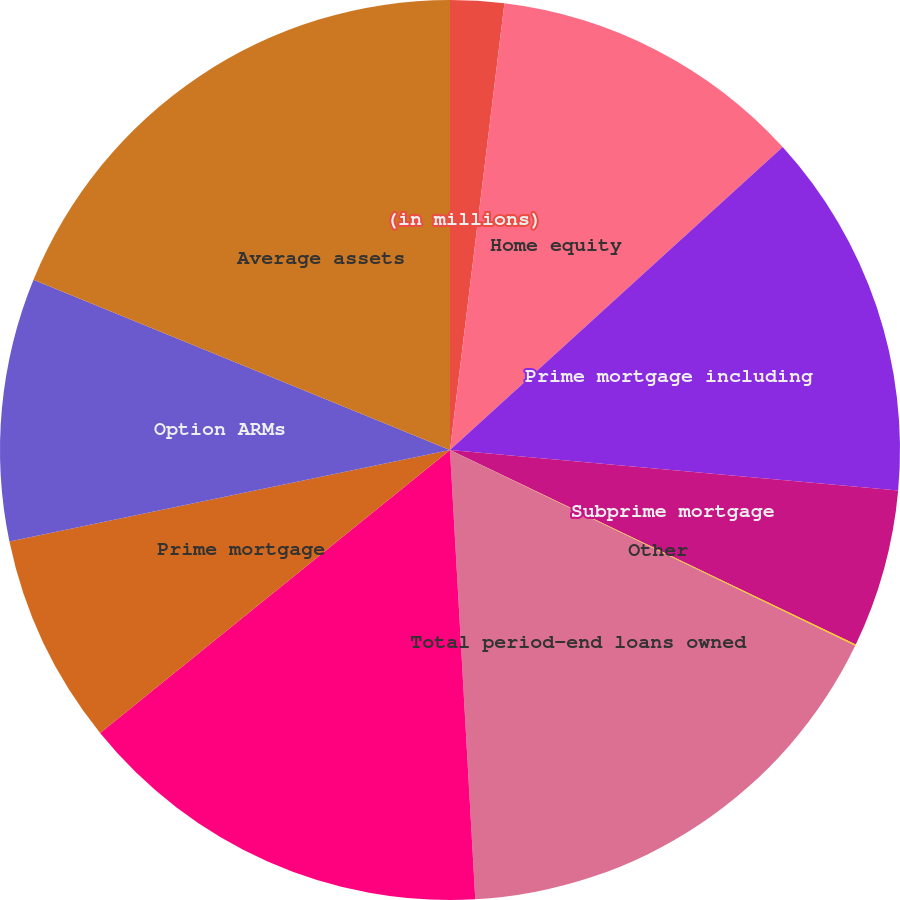Convert chart to OTSL. <chart><loc_0><loc_0><loc_500><loc_500><pie_chart><fcel>(in millions)<fcel>Home equity<fcel>Prime mortgage including<fcel>Subprime mortgage<fcel>Other<fcel>Total period-end loans owned<fcel>Total average loans owned<fcel>Prime mortgage<fcel>Option ARMs<fcel>Average assets<nl><fcel>1.93%<fcel>11.31%<fcel>13.19%<fcel>5.68%<fcel>0.05%<fcel>16.94%<fcel>15.07%<fcel>7.56%<fcel>9.44%<fcel>18.82%<nl></chart> 